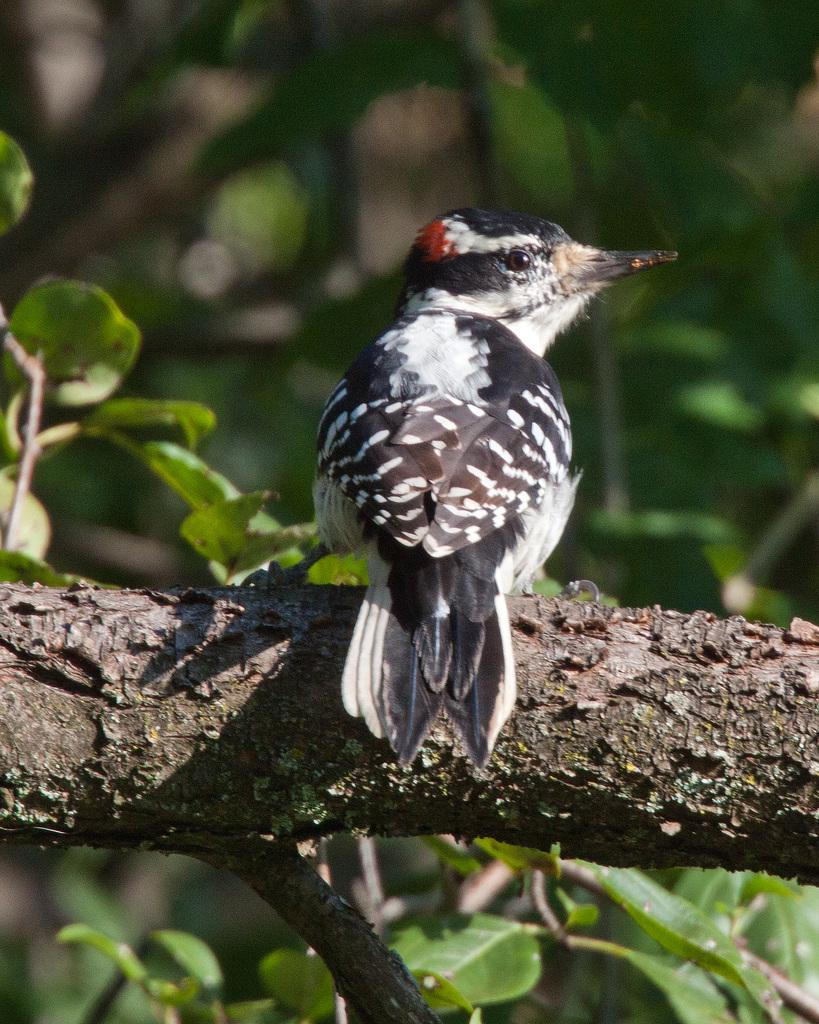Where was the image taken? The image was taken outdoors. What can be seen in the image besides the outdoor setting? There is a tree with leaves, stems, and branches in the image. Is there any wildlife present in the image? Yes, there is a bird on a branch of the tree in the image. What type of advertisement can be seen on the tree in the image? There is no advertisement present on the tree in the image; it is a natural scene with a tree and a bird. What type of harmony is being depicted in the image? The image does not depict any specific harmony; it is a snapshot of a tree and a bird in an outdoor setting. 